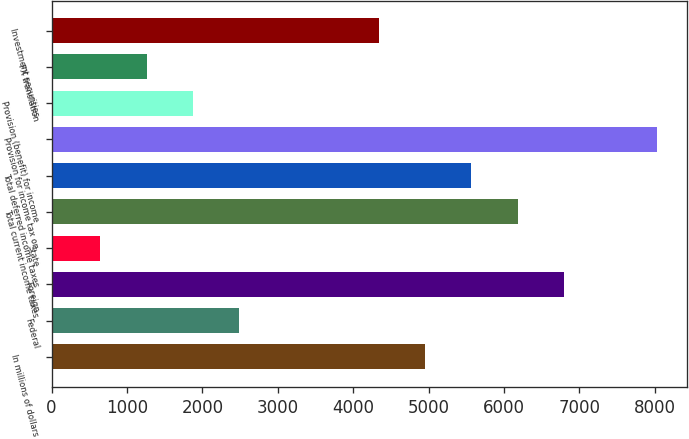<chart> <loc_0><loc_0><loc_500><loc_500><bar_chart><fcel>In millions of dollars<fcel>Federal<fcel>Foreign<fcel>State<fcel>Total current income taxes<fcel>Total deferred income taxes<fcel>Provision for income tax on<fcel>Provision (benefit) for income<fcel>FX translation<fcel>Investment securities<nl><fcel>4954.4<fcel>2491.2<fcel>6801.8<fcel>643.8<fcel>6186<fcel>5570.2<fcel>8033.4<fcel>1875.4<fcel>1259.6<fcel>4338.6<nl></chart> 